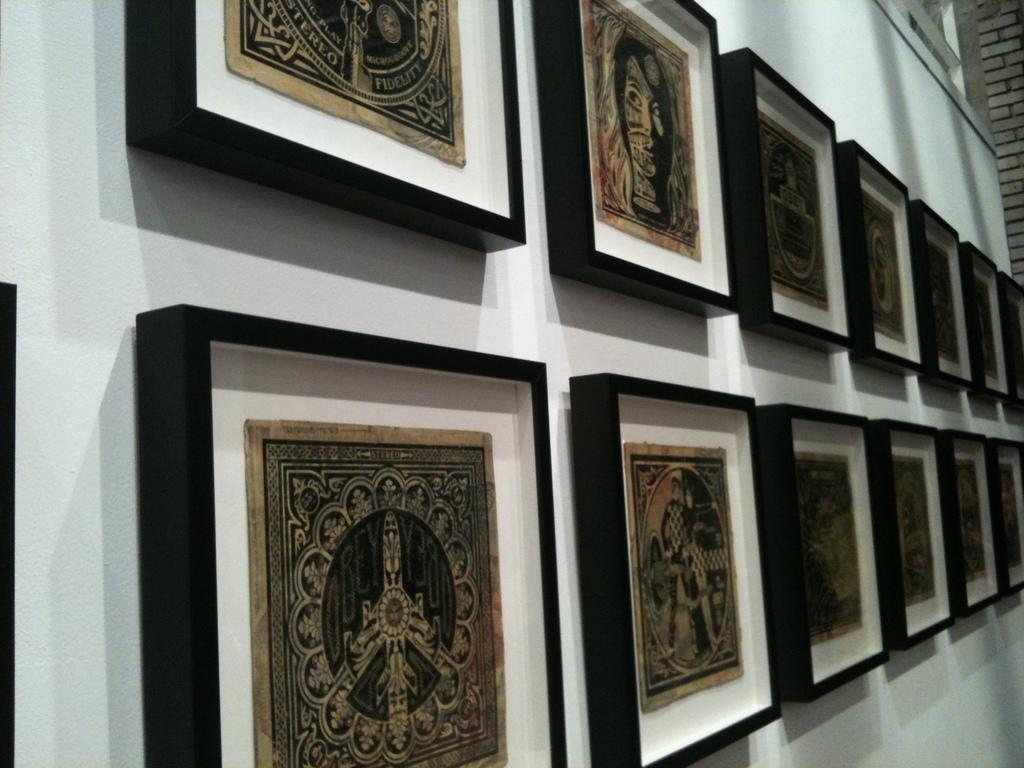What can be seen hanging on the wall in the image? There are frames with images on the wall in the image. What is the color of the borders around the frames? The frames have black color borders. What type of wall is visible in the top right corner of the image? There is a brick wall in the top right corner of the image. What time is displayed on the hour in the image? There is no hour or clock present in the image, so it is not possible to determine the time. Can you describe the chicken in the image? There is no chicken present in the image. 